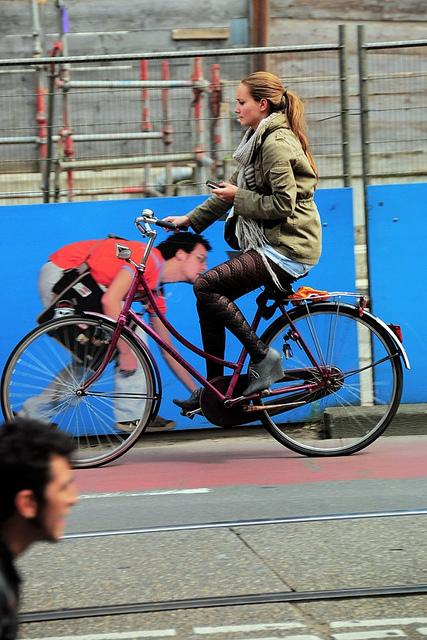What does the object use to speed? Please explain your reasoning. gears. These change how hard or easy it is to pedal 